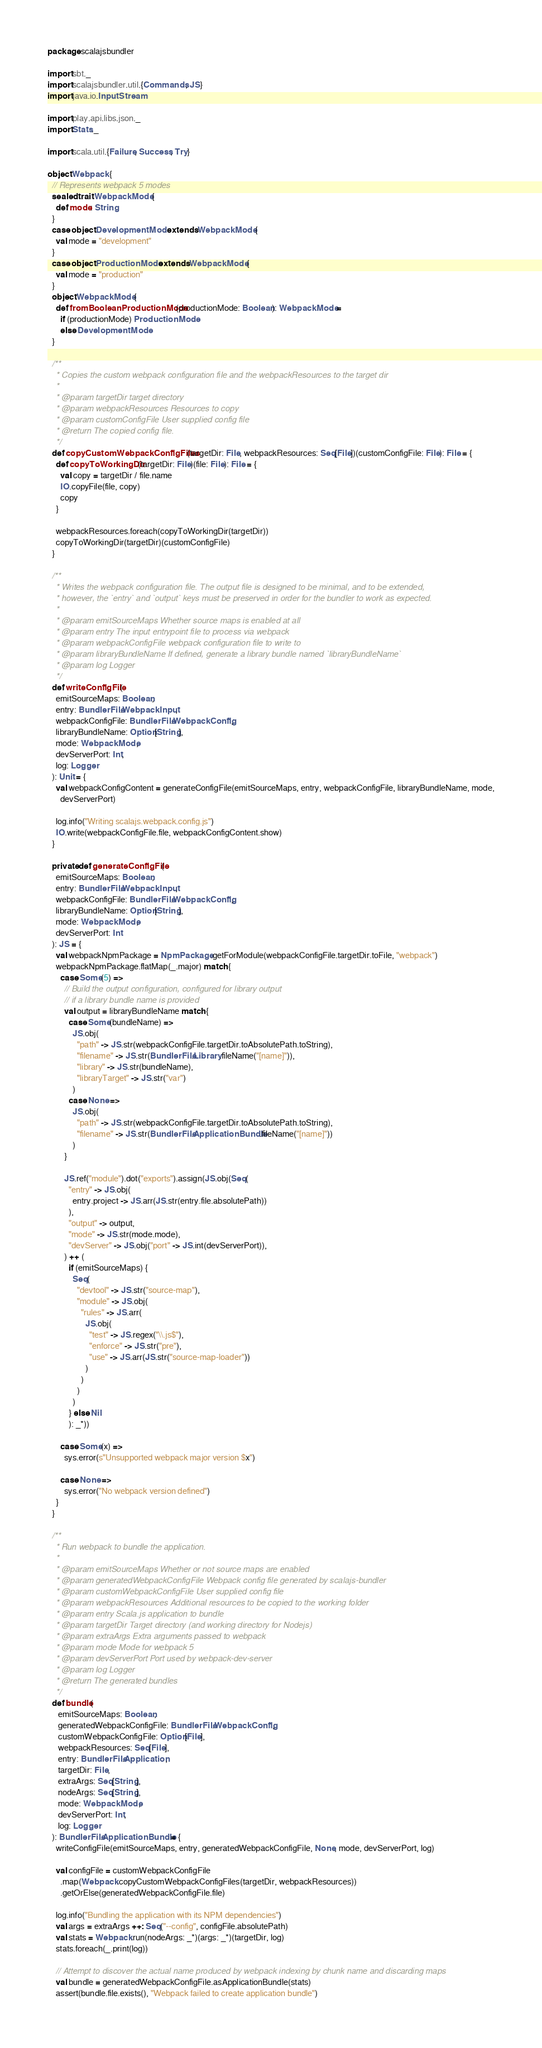Convert code to text. <code><loc_0><loc_0><loc_500><loc_500><_Scala_>package scalajsbundler

import sbt._
import scalajsbundler.util.{Commands, JS}
import java.io.InputStream

import play.api.libs.json._
import Stats._

import scala.util.{Failure, Success, Try}

object Webpack {
  // Represents webpack 5 modes
  sealed trait WebpackMode {
    def mode: String
  }
  case object DevelopmentMode extends WebpackMode {
    val mode = "development"
  }
  case object ProductionMode extends WebpackMode {
    val mode = "production"
  }
  object WebpackMode {
    def fromBooleanProductionMode(productionMode: Boolean): WebpackMode =
      if (productionMode) ProductionMode
      else DevelopmentMode
  }

  /**
    * Copies the custom webpack configuration file and the webpackResources to the target dir
    *
    * @param targetDir target directory
    * @param webpackResources Resources to copy
    * @param customConfigFile User supplied config file
    * @return The copied config file.
    */
  def copyCustomWebpackConfigFiles(targetDir: File, webpackResources: Seq[File])(customConfigFile: File): File = {
    def copyToWorkingDir(targetDir: File)(file: File): File = {
      val copy = targetDir / file.name
      IO.copyFile(file, copy)
      copy
    }

    webpackResources.foreach(copyToWorkingDir(targetDir))
    copyToWorkingDir(targetDir)(customConfigFile)
  }

  /**
    * Writes the webpack configuration file. The output file is designed to be minimal, and to be extended,
    * however, the `entry` and `output` keys must be preserved in order for the bundler to work as expected.
    *
    * @param emitSourceMaps Whether source maps is enabled at all
    * @param entry The input entrypoint file to process via webpack
    * @param webpackConfigFile webpack configuration file to write to
    * @param libraryBundleName If defined, generate a library bundle named `libraryBundleName`
    * @param log Logger
    */
  def writeConfigFile(
    emitSourceMaps: Boolean,
    entry: BundlerFile.WebpackInput,
    webpackConfigFile: BundlerFile.WebpackConfig,
    libraryBundleName: Option[String],
    mode: WebpackMode,
    devServerPort: Int,
    log: Logger
  ): Unit = {
    val webpackConfigContent = generateConfigFile(emitSourceMaps, entry, webpackConfigFile, libraryBundleName, mode,
      devServerPort)

    log.info("Writing scalajs.webpack.config.js")
    IO.write(webpackConfigFile.file, webpackConfigContent.show)
  }

  private def generateConfigFile(
    emitSourceMaps: Boolean,
    entry: BundlerFile.WebpackInput,
    webpackConfigFile: BundlerFile.WebpackConfig,
    libraryBundleName: Option[String],
    mode: WebpackMode,
    devServerPort: Int
  ): JS = {
    val webpackNpmPackage = NpmPackage.getForModule(webpackConfigFile.targetDir.toFile, "webpack")
    webpackNpmPackage.flatMap(_.major) match {
      case Some(5) =>
        // Build the output configuration, configured for library output
        // if a library bundle name is provided
        val output = libraryBundleName match {
          case Some(bundleName) =>
            JS.obj(
              "path" -> JS.str(webpackConfigFile.targetDir.toAbsolutePath.toString),
              "filename" -> JS.str(BundlerFile.Library.fileName("[name]")),
              "library" -> JS.str(bundleName),
              "libraryTarget" -> JS.str("var")
            )
          case None =>
            JS.obj(
              "path" -> JS.str(webpackConfigFile.targetDir.toAbsolutePath.toString),
              "filename" -> JS.str(BundlerFile.ApplicationBundle.fileName("[name]"))
            )
        }

        JS.ref("module").dot("exports").assign(JS.obj(Seq(
          "entry" -> JS.obj(
            entry.project -> JS.arr(JS.str(entry.file.absolutePath))
          ),
          "output" -> output,
          "mode" -> JS.str(mode.mode),
          "devServer" -> JS.obj("port" -> JS.int(devServerPort)),
        ) ++ (
          if (emitSourceMaps) {
            Seq(
              "devtool" -> JS.str("source-map"),
              "module" -> JS.obj(
                "rules" -> JS.arr(
                  JS.obj(
                    "test" -> JS.regex("\\.js$"),
                    "enforce" -> JS.str("pre"),
                    "use" -> JS.arr(JS.str("source-map-loader"))
                  )
                )
              )
            )
          } else Nil
          ): _*))

      case Some(x) =>
        sys.error(s"Unsupported webpack major version $x")

      case None =>
        sys.error("No webpack version defined")
    }
  }

  /**
    * Run webpack to bundle the application.
    *
    * @param emitSourceMaps Whether or not source maps are enabled
    * @param generatedWebpackConfigFile Webpack config file generated by scalajs-bundler
    * @param customWebpackConfigFile User supplied config file
    * @param webpackResources Additional resources to be copied to the working folder
    * @param entry Scala.js application to bundle
    * @param targetDir Target directory (and working directory for Nodejs)
    * @param extraArgs Extra arguments passed to webpack
    * @param mode Mode for webpack 5
    * @param devServerPort Port used by webpack-dev-server
    * @param log Logger
    * @return The generated bundles
    */
  def bundle(
     emitSourceMaps: Boolean,
     generatedWebpackConfigFile: BundlerFile.WebpackConfig,
     customWebpackConfigFile: Option[File],
     webpackResources: Seq[File],
     entry: BundlerFile.Application,
     targetDir: File,
     extraArgs: Seq[String],
     nodeArgs: Seq[String],
     mode: WebpackMode,
     devServerPort: Int,
     log: Logger
  ): BundlerFile.ApplicationBundle = {
    writeConfigFile(emitSourceMaps, entry, generatedWebpackConfigFile, None, mode, devServerPort, log)

    val configFile = customWebpackConfigFile
      .map(Webpack.copyCustomWebpackConfigFiles(targetDir, webpackResources))
      .getOrElse(generatedWebpackConfigFile.file)

    log.info("Bundling the application with its NPM dependencies")
    val args = extraArgs ++: Seq("--config", configFile.absolutePath)
    val stats = Webpack.run(nodeArgs: _*)(args: _*)(targetDir, log)
    stats.foreach(_.print(log))

    // Attempt to discover the actual name produced by webpack indexing by chunk name and discarding maps
    val bundle = generatedWebpackConfigFile.asApplicationBundle(stats)
    assert(bundle.file.exists(), "Webpack failed to create application bundle")</code> 